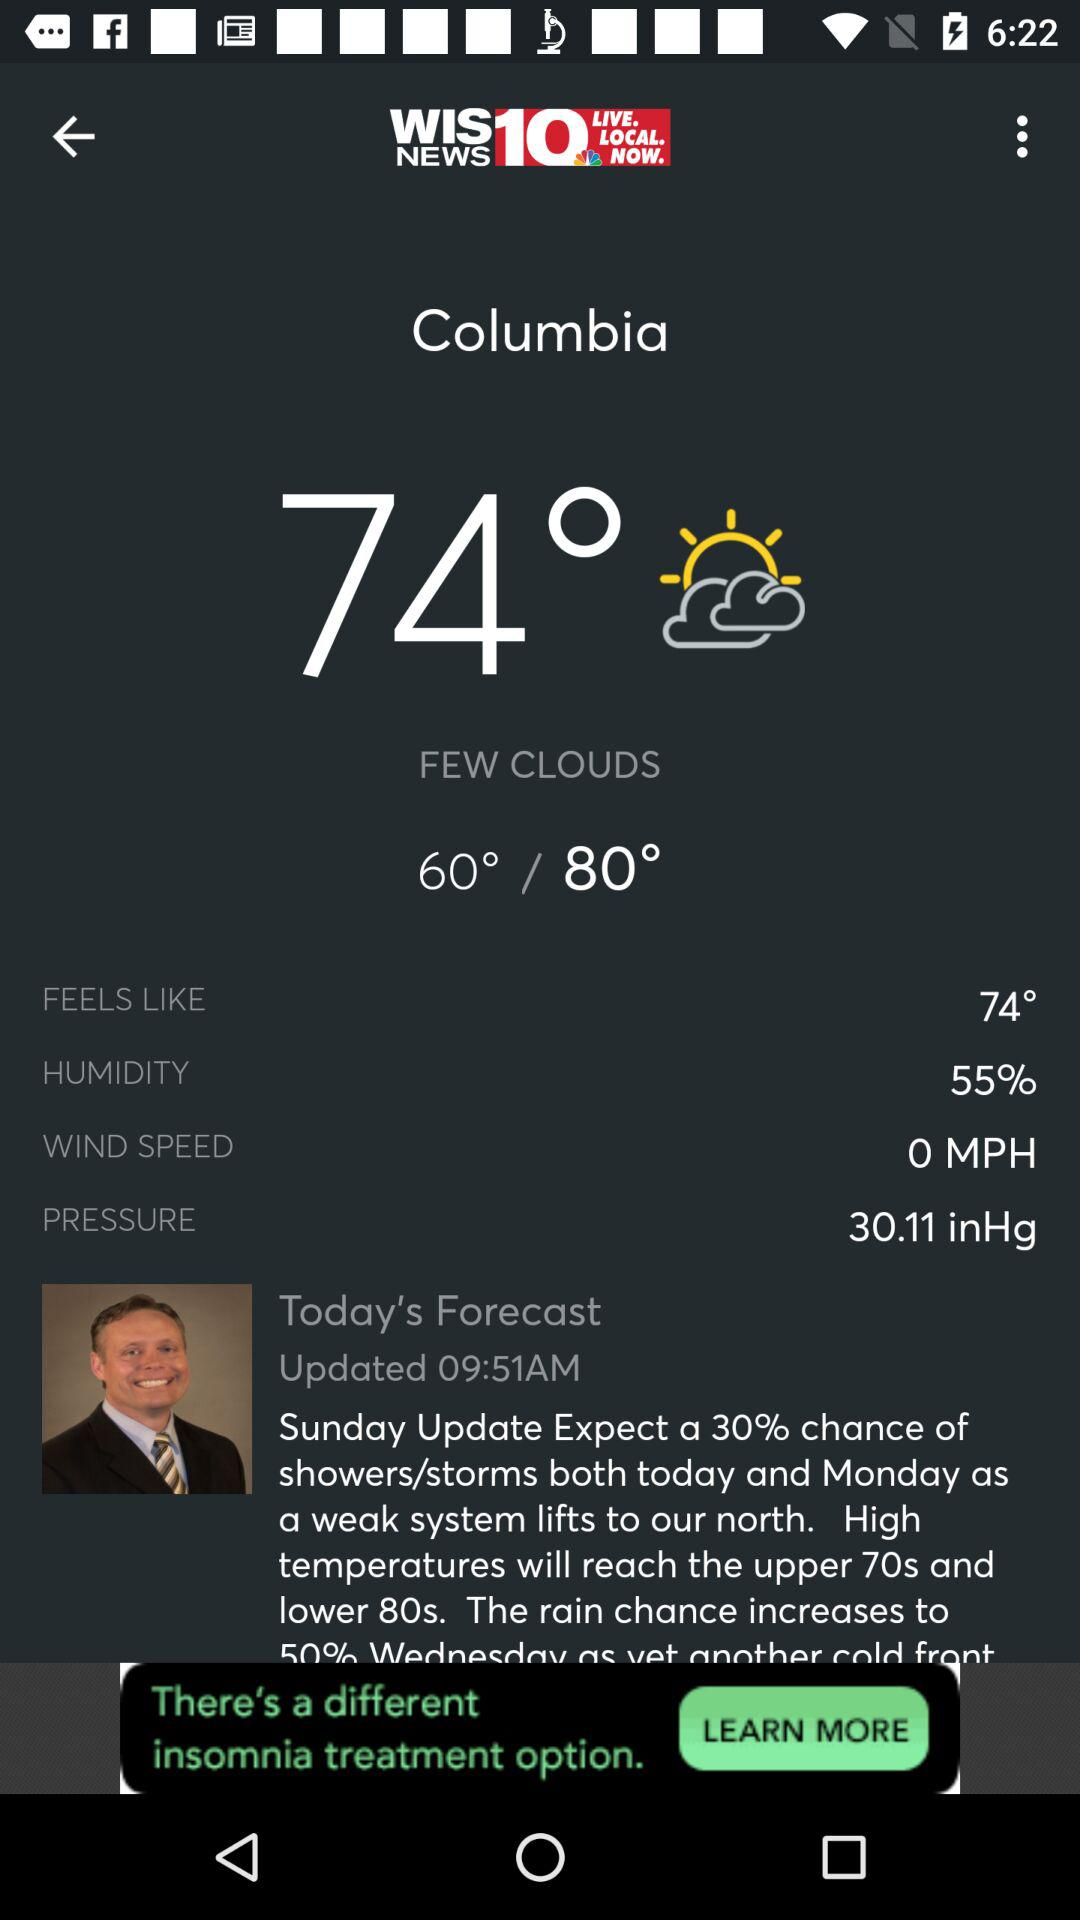What is the humidity percentage?
Answer the question using a single word or phrase. 55% 